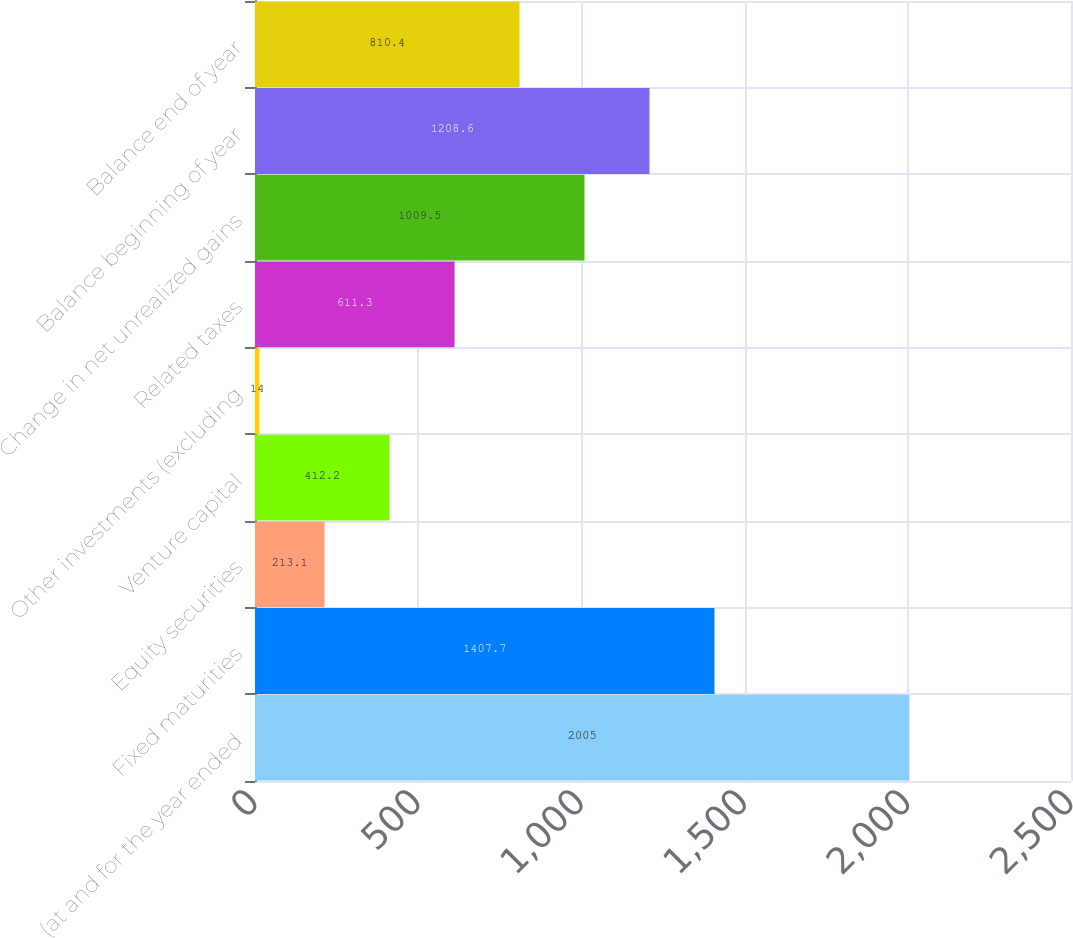<chart> <loc_0><loc_0><loc_500><loc_500><bar_chart><fcel>(at and for the year ended<fcel>Fixed maturities<fcel>Equity securities<fcel>Venture capital<fcel>Other investments (excluding<fcel>Related taxes<fcel>Change in net unrealized gains<fcel>Balance beginning of year<fcel>Balance end of year<nl><fcel>2005<fcel>1407.7<fcel>213.1<fcel>412.2<fcel>14<fcel>611.3<fcel>1009.5<fcel>1208.6<fcel>810.4<nl></chart> 